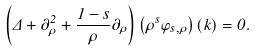Convert formula to latex. <formula><loc_0><loc_0><loc_500><loc_500>\left ( \Delta + \partial _ { \rho } ^ { 2 } + \frac { 1 - s } { \rho } \partial _ { \rho } \right ) \left ( \rho ^ { s } \varphi _ { s , \rho } \right ) ( k ) = 0 .</formula> 